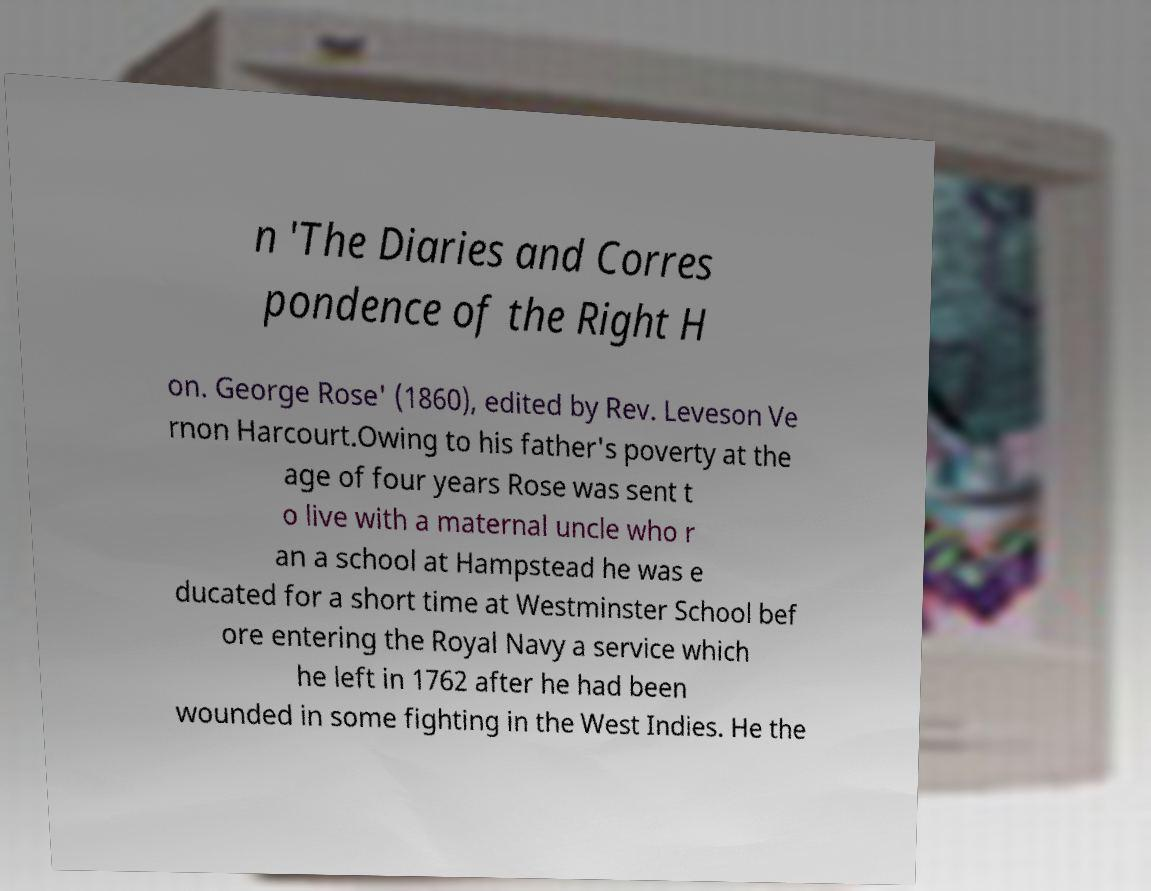Can you accurately transcribe the text from the provided image for me? n 'The Diaries and Corres pondence of the Right H on. George Rose' (1860), edited by Rev. Leveson Ve rnon Harcourt.Owing to his father's poverty at the age of four years Rose was sent t o live with a maternal uncle who r an a school at Hampstead he was e ducated for a short time at Westminster School bef ore entering the Royal Navy a service which he left in 1762 after he had been wounded in some fighting in the West Indies. He the 